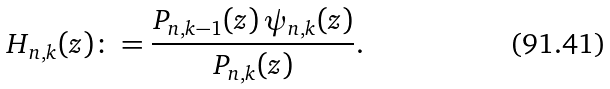<formula> <loc_0><loc_0><loc_500><loc_500>H _ { n , k } ( z ) \colon = \frac { P _ { n , k - 1 } ( z ) \, \psi _ { n , k } ( z ) } { P _ { n , k } ( z ) } .</formula> 